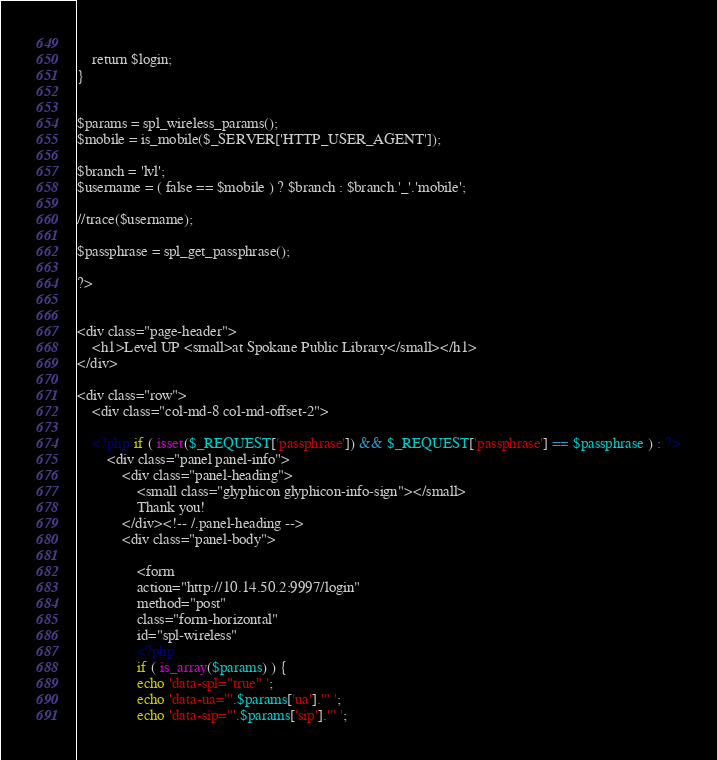<code> <loc_0><loc_0><loc_500><loc_500><_PHP_>    
    return $login;
}


$params = spl_wireless_params();
$mobile = is_mobile($_SERVER['HTTP_USER_AGENT']);

$branch = 'lvl';
$username = ( false == $mobile ) ? $branch : $branch.'_'.'mobile';  

//trace($username);

$passphrase = spl_get_passphrase();

?>


<div class="page-header">
    <h1>Level UP <small>at Spokane Public Library</small></h1>
</div>

<div class="row">
    <div class="col-md-8 col-md-offset-2">

    <?php if ( isset($_REQUEST['passphrase']) && $_REQUEST['passphrase'] == $passphrase ) : ?>
        <div class="panel panel-info">
            <div class="panel-heading">
                <small class="glyphicon glyphicon-info-sign"></small>
                Thank you!
            </div><!-- /.panel-heading -->
            <div class="panel-body">

                <form 
                action="http://10.14.50.2:9997/login" 
                method="post" 
                class="form-horizontal"
                id="spl-wireless" 
                <?php
                if ( is_array($params) ) {
                echo 'data-spl="true" ';
                echo 'data-ua="'.$params['ua'].'" ';
                echo 'data-sip="'.$params['sip'].'" ';</code> 